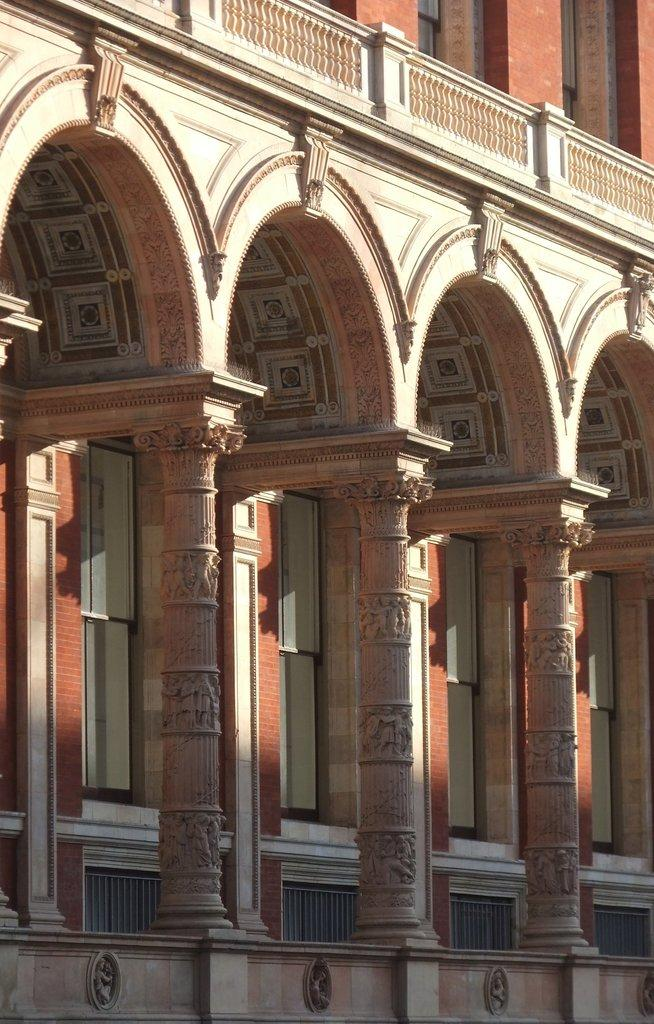What is the main structure visible in the image? There is a building in the image. Can you describe any specific features of the building? The building has three pillars in the front. Where is the faucet located in the image? There is no faucet present in the image. What type of patch is visible on the building in the image? There is no patch visible on the building in the image. 